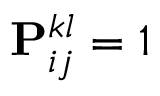Convert formula to latex. <formula><loc_0><loc_0><loc_500><loc_500>P _ { i j } ^ { k l } = 1</formula> 